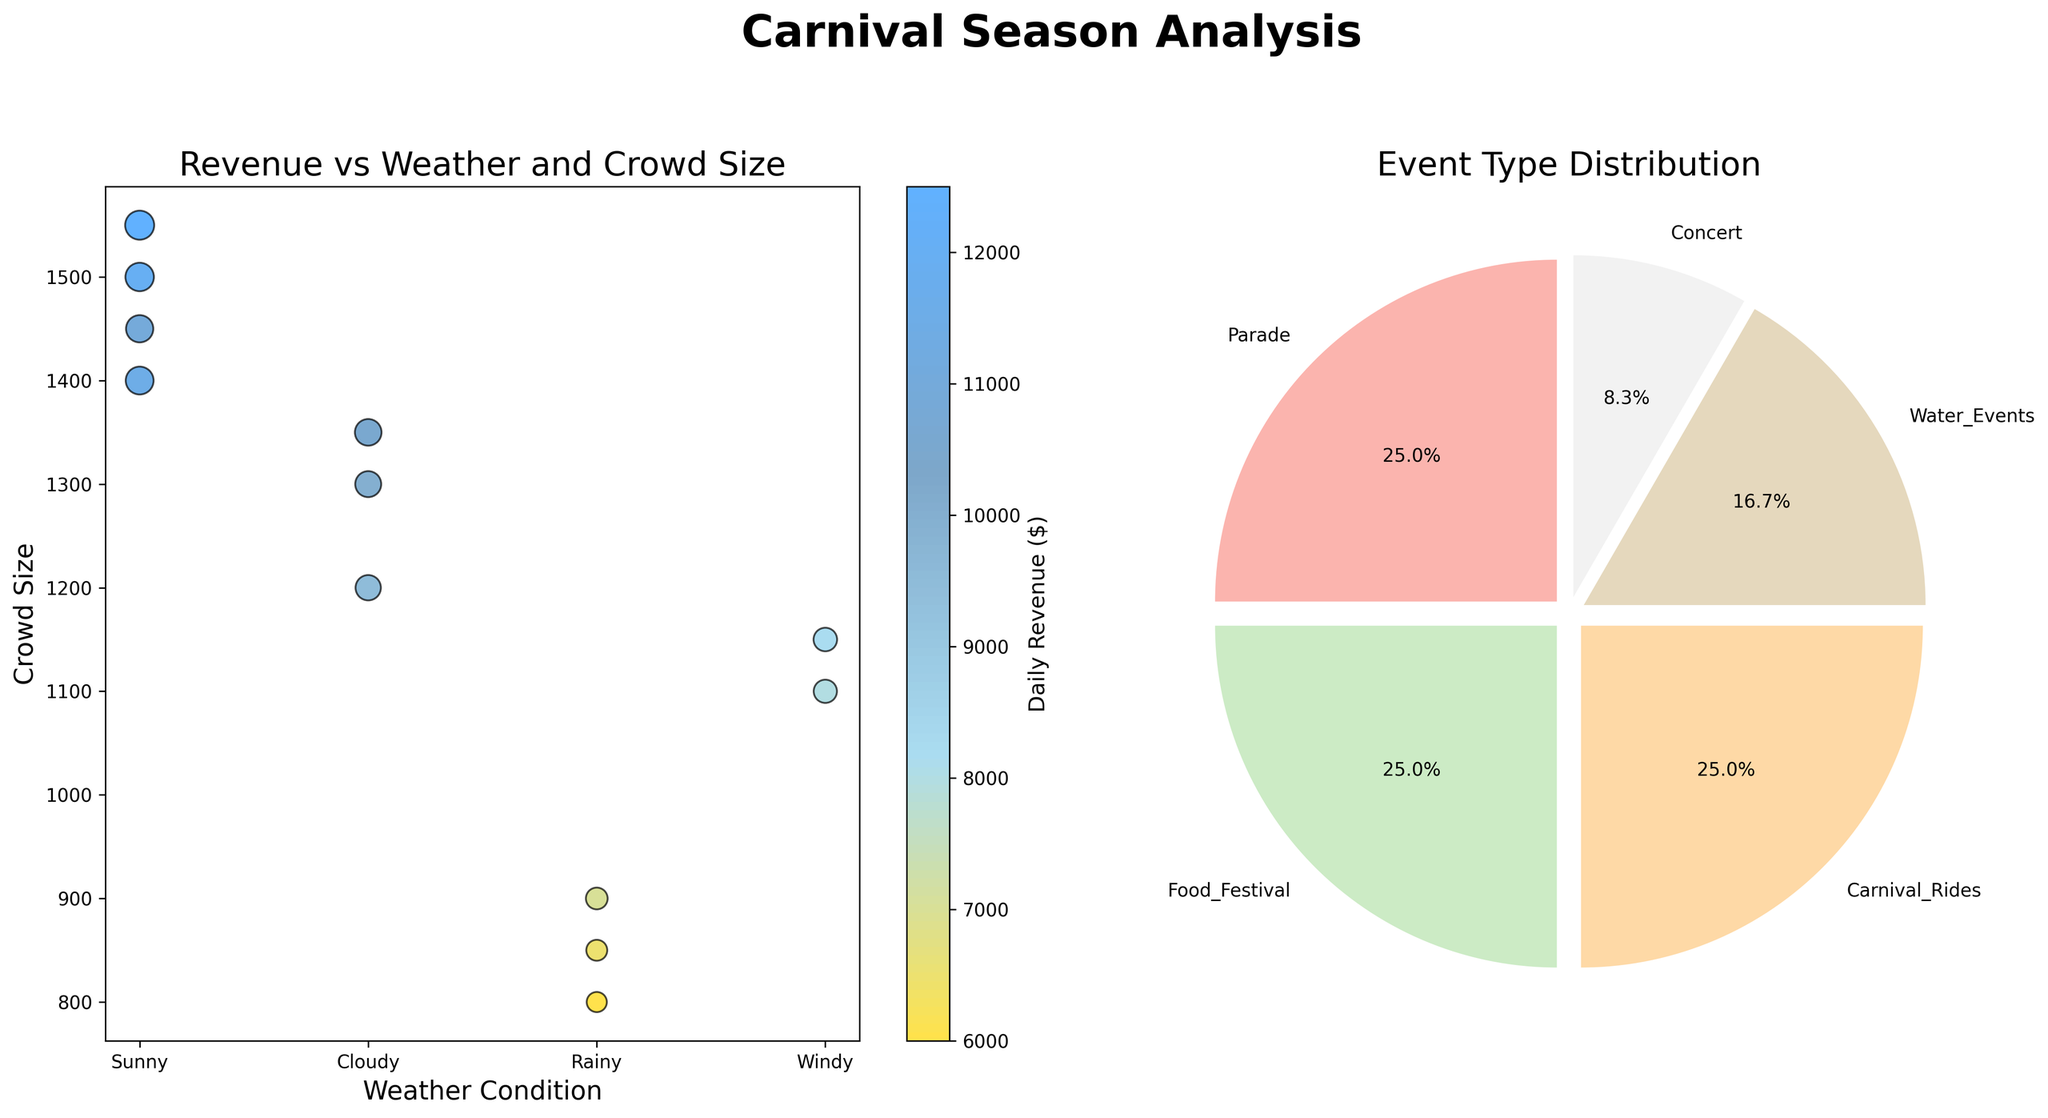What is the title of the scatter plot on the left side? The title of the scatter plot on the left side can be found directly above the scatter plot.
Answer: Revenue vs Weather and Crowd Size What do the colors in the scatter plot represent? The colors in the scatter plot correspond to daily revenue, which can be interpreted using the colored bar on the side (color legend).
Answer: Daily Revenue What weather condition has the highest daily revenue data point? By observing the scatter plot, find the point with the highest daily revenue and refer to its position on the x-axis to determine the weather condition.
Answer: Sunny How many different weather conditions are displayed in the scatter plot? Looking at the x-axis of the scatter plot, count the different labels representing weather conditions.
Answer: Four Which event type occurs most frequently during the carnival season? Refer to the pie chart on the right side. The largest wedge and its corresponding label indicate the most frequently occurring event type.
Answer: Parade Which weather condition shows the largest crowd size? Identify the highest data points on the y-axis of the scatter plot and check their corresponding weather conditions on the x-axis.
Answer: Sunny What is the total percentage of events that are Concerts and Carnival Rides combined? Locate the percentages for Concerts and Carnival Rides in the pie chart and add them together.
Answer: 33.3% Which weather condition is associated with the smallest crowd size? Find the smallest data points on the y-axis of the scatter plot and check their corresponding weather conditions on the x-axis.
Answer: Rainy Between Cloudy and Windy weather conditions, which one has a higher average daily revenue? Calculate the average daily revenue for both Cloudy and Windy weather conditions based on the scatter plot.
Answer: Cloudy What is the relationship between crowd size and daily revenue based on the scatter plot? Observe whether larger crowd sizes generally correspond to higher daily revenues and vice versa.
Answer: Larger crowd sizes generally correspond to higher daily revenues 